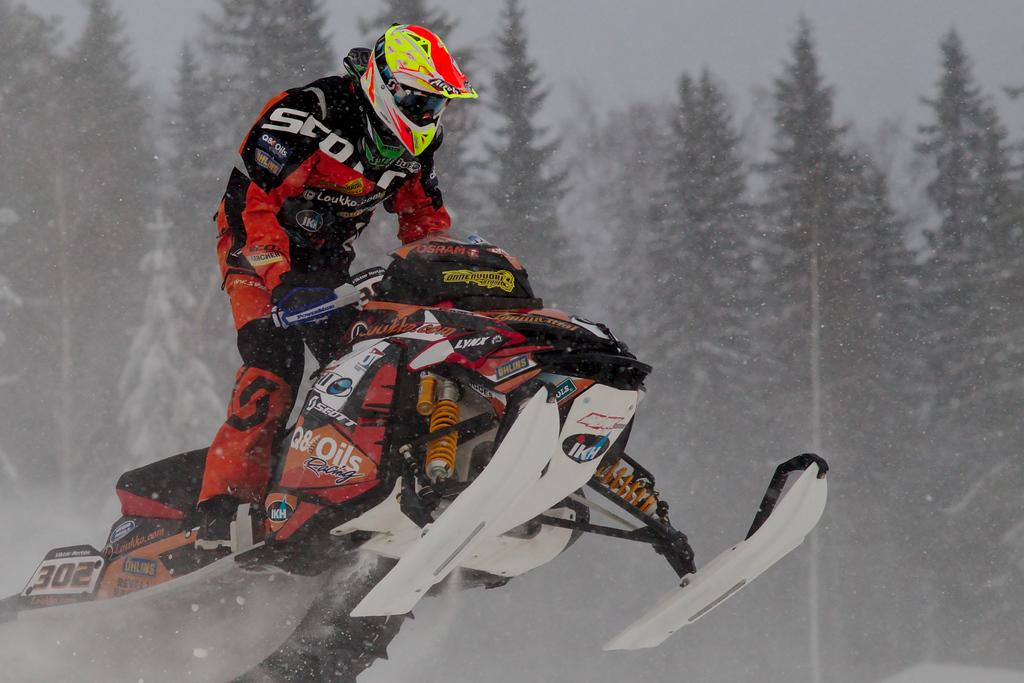What is the main subject of the image? There is a man in the image. What activity is the man engaged in? The man is performing winter sports. What can be seen in the background of the image? There are trees in the background of the image. How many birds are flying in the image? There are no birds visible in the image. What question is the man asking in the image? The image does not show the man asking a question. 